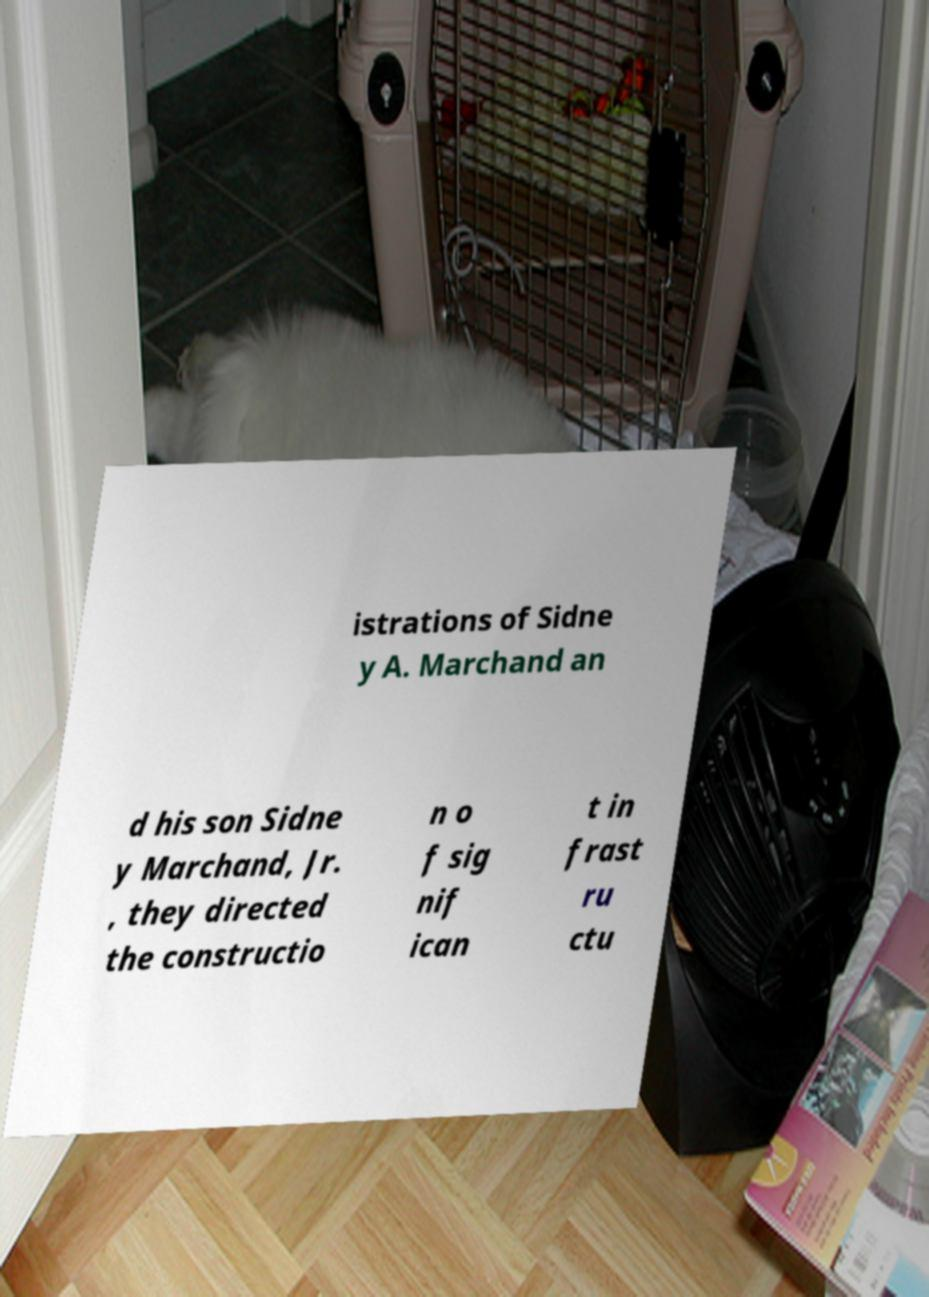Can you read and provide the text displayed in the image?This photo seems to have some interesting text. Can you extract and type it out for me? istrations of Sidne y A. Marchand an d his son Sidne y Marchand, Jr. , they directed the constructio n o f sig nif ican t in frast ru ctu 